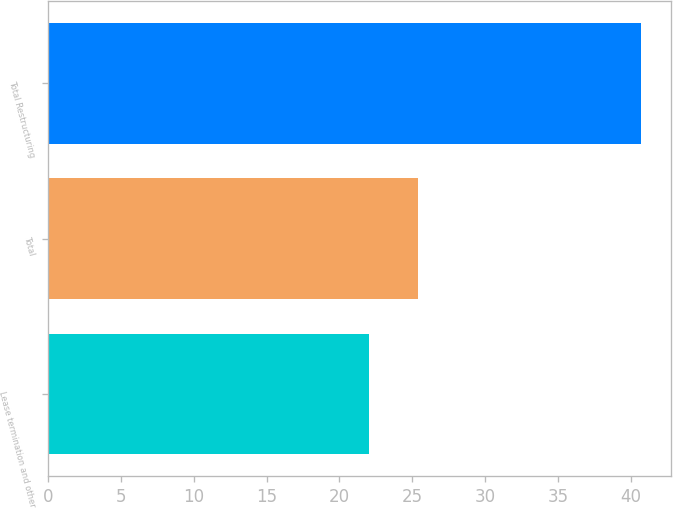<chart> <loc_0><loc_0><loc_500><loc_500><bar_chart><fcel>Lease termination and other<fcel>Total<fcel>Total Restructuring<nl><fcel>22<fcel>25.4<fcel>40.7<nl></chart> 